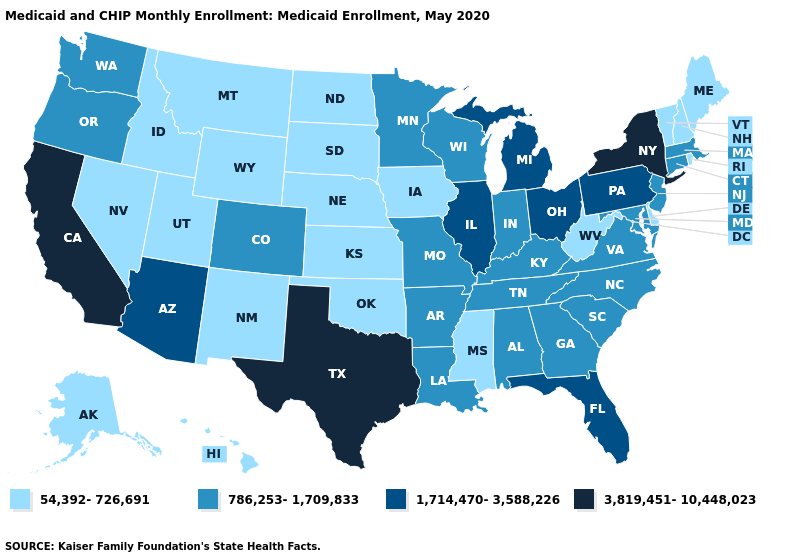Does California have the highest value in the USA?
Answer briefly. Yes. Among the states that border South Dakota , does Minnesota have the highest value?
Short answer required. Yes. What is the lowest value in the USA?
Short answer required. 54,392-726,691. What is the lowest value in states that border Ohio?
Give a very brief answer. 54,392-726,691. Name the states that have a value in the range 786,253-1,709,833?
Give a very brief answer. Alabama, Arkansas, Colorado, Connecticut, Georgia, Indiana, Kentucky, Louisiana, Maryland, Massachusetts, Minnesota, Missouri, New Jersey, North Carolina, Oregon, South Carolina, Tennessee, Virginia, Washington, Wisconsin. How many symbols are there in the legend?
Write a very short answer. 4. Name the states that have a value in the range 3,819,451-10,448,023?
Give a very brief answer. California, New York, Texas. What is the value of Colorado?
Write a very short answer. 786,253-1,709,833. What is the lowest value in the USA?
Give a very brief answer. 54,392-726,691. What is the lowest value in states that border Indiana?
Answer briefly. 786,253-1,709,833. What is the value of Pennsylvania?
Write a very short answer. 1,714,470-3,588,226. Which states have the lowest value in the USA?
Short answer required. Alaska, Delaware, Hawaii, Idaho, Iowa, Kansas, Maine, Mississippi, Montana, Nebraska, Nevada, New Hampshire, New Mexico, North Dakota, Oklahoma, Rhode Island, South Dakota, Utah, Vermont, West Virginia, Wyoming. Is the legend a continuous bar?
Be succinct. No. Does Iowa have the lowest value in the USA?
Keep it brief. Yes. 